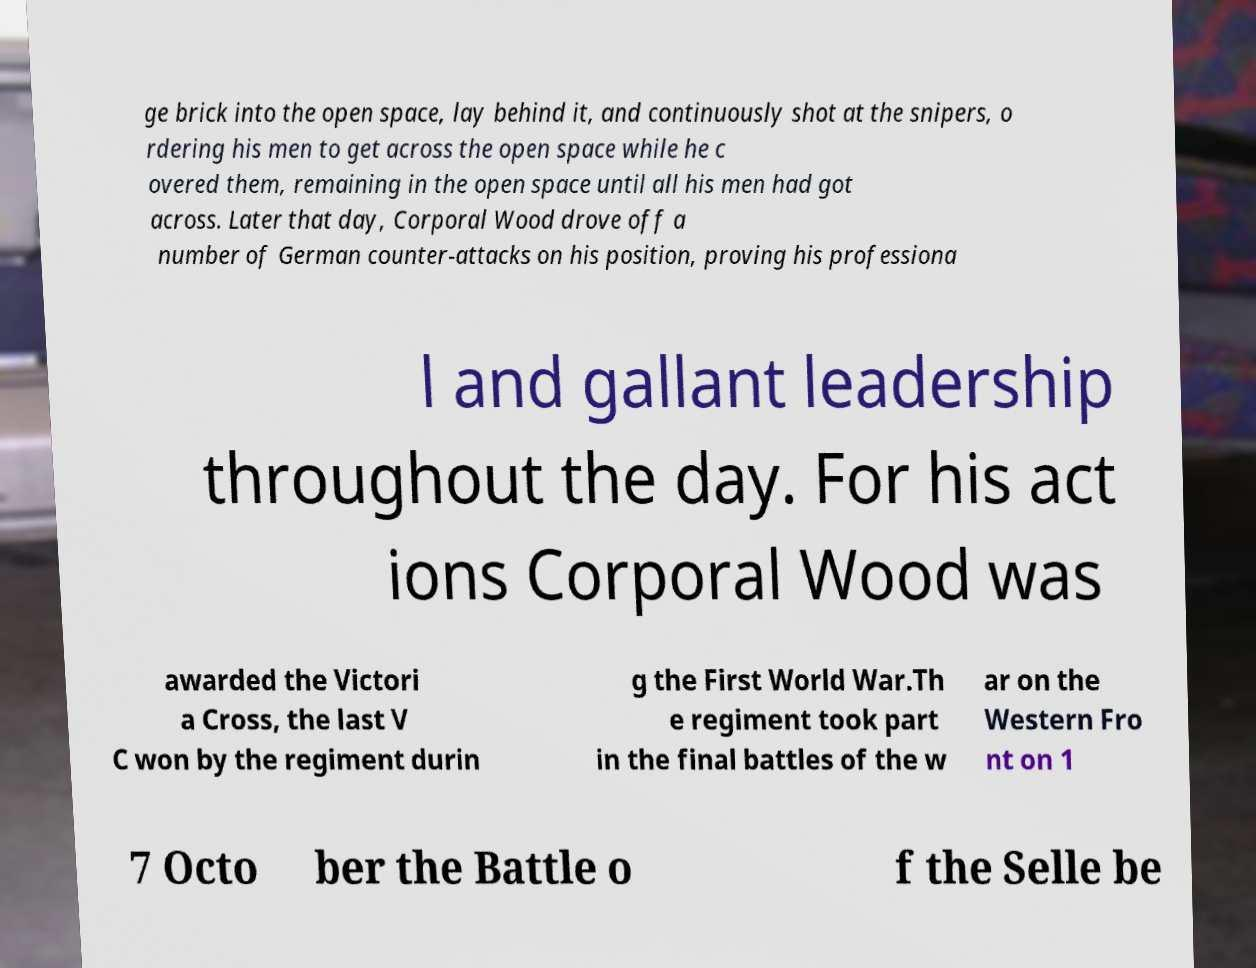Please identify and transcribe the text found in this image. ge brick into the open space, lay behind it, and continuously shot at the snipers, o rdering his men to get across the open space while he c overed them, remaining in the open space until all his men had got across. Later that day, Corporal Wood drove off a number of German counter-attacks on his position, proving his professiona l and gallant leadership throughout the day. For his act ions Corporal Wood was awarded the Victori a Cross, the last V C won by the regiment durin g the First World War.Th e regiment took part in the final battles of the w ar on the Western Fro nt on 1 7 Octo ber the Battle o f the Selle be 